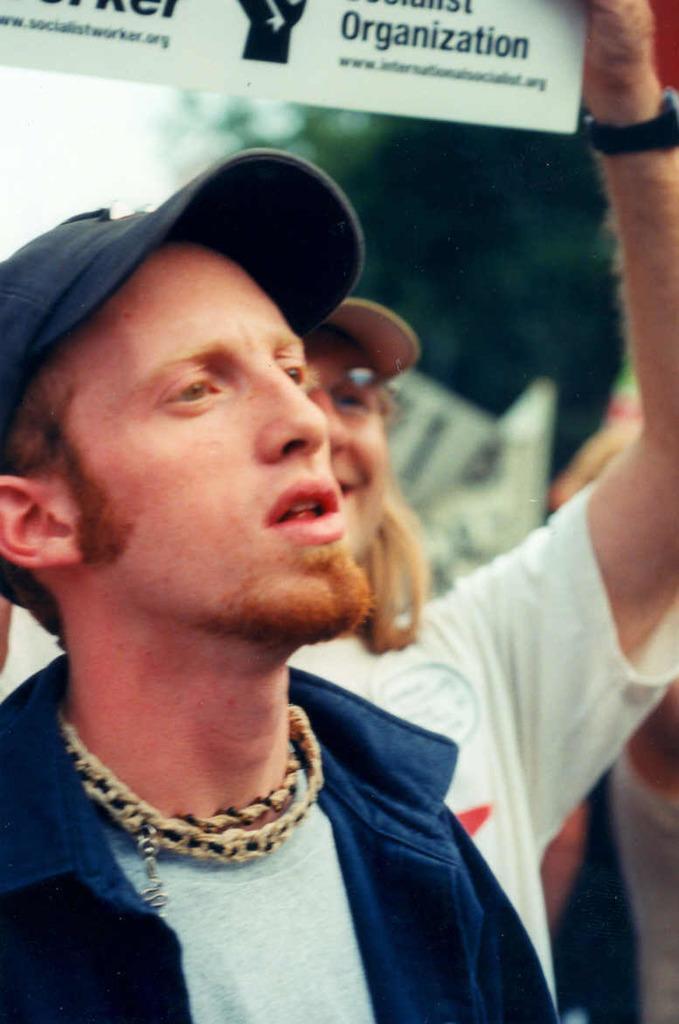Please provide a concise description of this image. This image is taken outdoors. In the background there is a tree and there are a few people. In the middle of the image there is a man and a woman. A woman is holding a board with a text in her hand. 